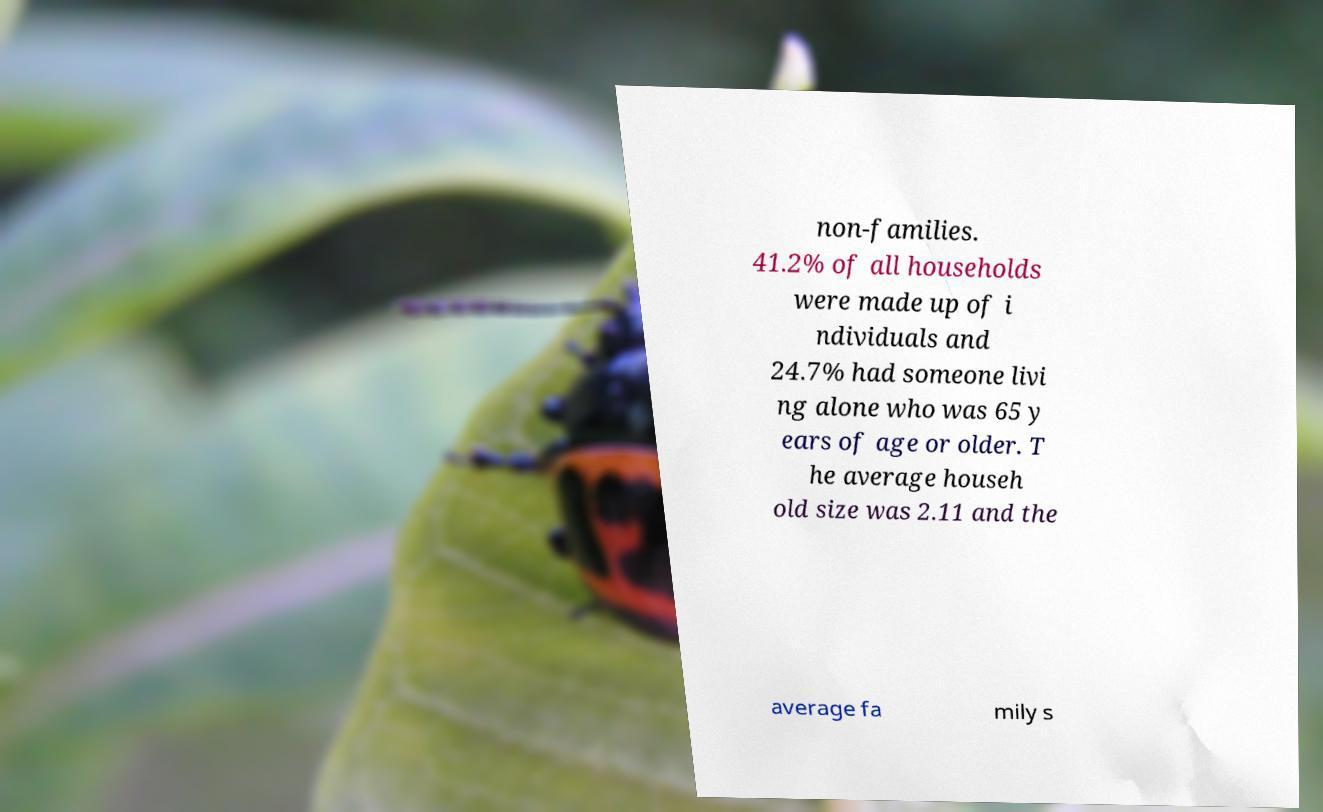Could you assist in decoding the text presented in this image and type it out clearly? non-families. 41.2% of all households were made up of i ndividuals and 24.7% had someone livi ng alone who was 65 y ears of age or older. T he average househ old size was 2.11 and the average fa mily s 